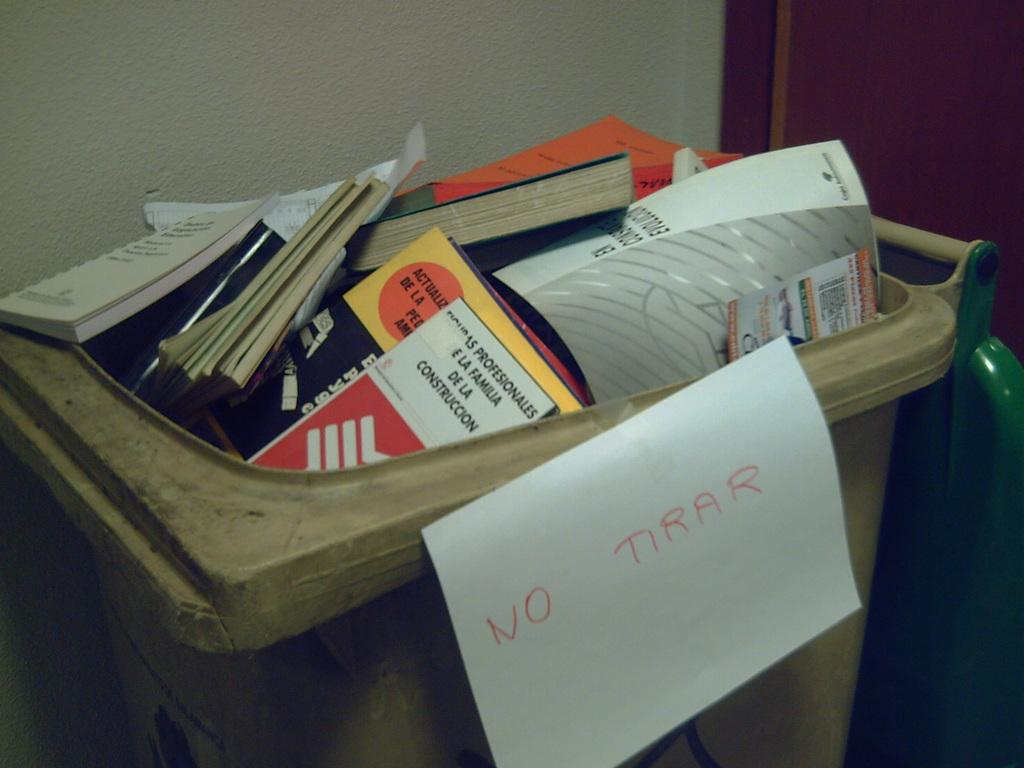<image>
Give a short and clear explanation of the subsequent image. White NO Tirar sign stuck on a bin full of random items. 